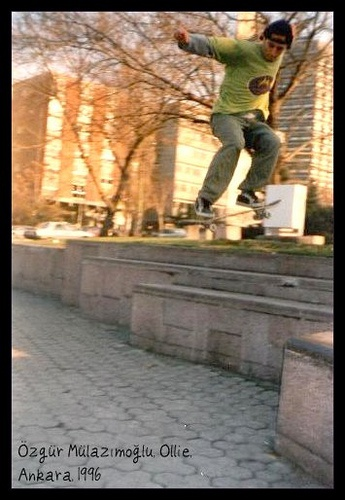Describe the objects in this image and their specific colors. I can see people in black, olive, and gray tones, car in black, beige, and tan tones, skateboard in black, tan, maroon, and gray tones, and car in black, tan, and gray tones in this image. 